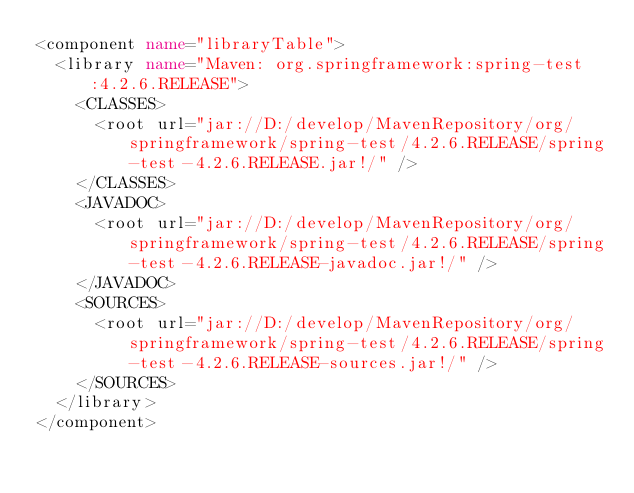Convert code to text. <code><loc_0><loc_0><loc_500><loc_500><_XML_><component name="libraryTable">
  <library name="Maven: org.springframework:spring-test:4.2.6.RELEASE">
    <CLASSES>
      <root url="jar://D:/develop/MavenRepository/org/springframework/spring-test/4.2.6.RELEASE/spring-test-4.2.6.RELEASE.jar!/" />
    </CLASSES>
    <JAVADOC>
      <root url="jar://D:/develop/MavenRepository/org/springframework/spring-test/4.2.6.RELEASE/spring-test-4.2.6.RELEASE-javadoc.jar!/" />
    </JAVADOC>
    <SOURCES>
      <root url="jar://D:/develop/MavenRepository/org/springframework/spring-test/4.2.6.RELEASE/spring-test-4.2.6.RELEASE-sources.jar!/" />
    </SOURCES>
  </library>
</component></code> 